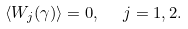Convert formula to latex. <formula><loc_0><loc_0><loc_500><loc_500>\langle W _ { j } ( \gamma ) \rangle = 0 , \ \ j = 1 , 2 .</formula> 